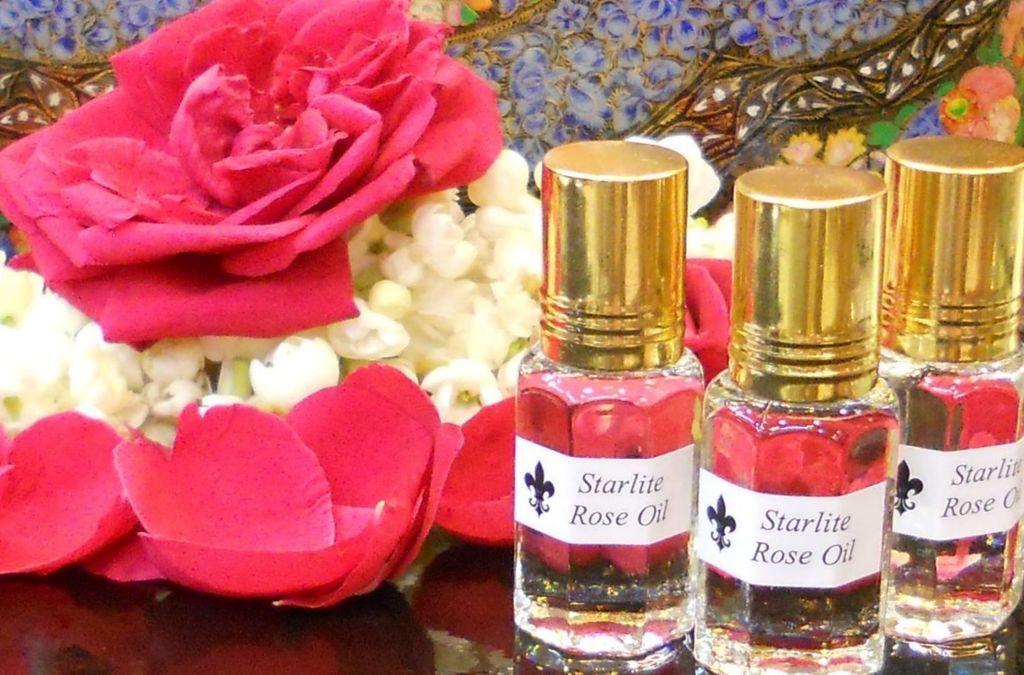What objects can be seen in the image? There are bottles and flowers in the image. Can you describe the bottles in the image? The bottles are the main objects visible in the image, but their specific characteristics are not mentioned in the provided facts. What other type of object is present in the image besides the bottles? There are flowers in the image. What reason does the beggar give for not accepting the button in the image? There is no beggar or button present in the image, so this question cannot be answered. 